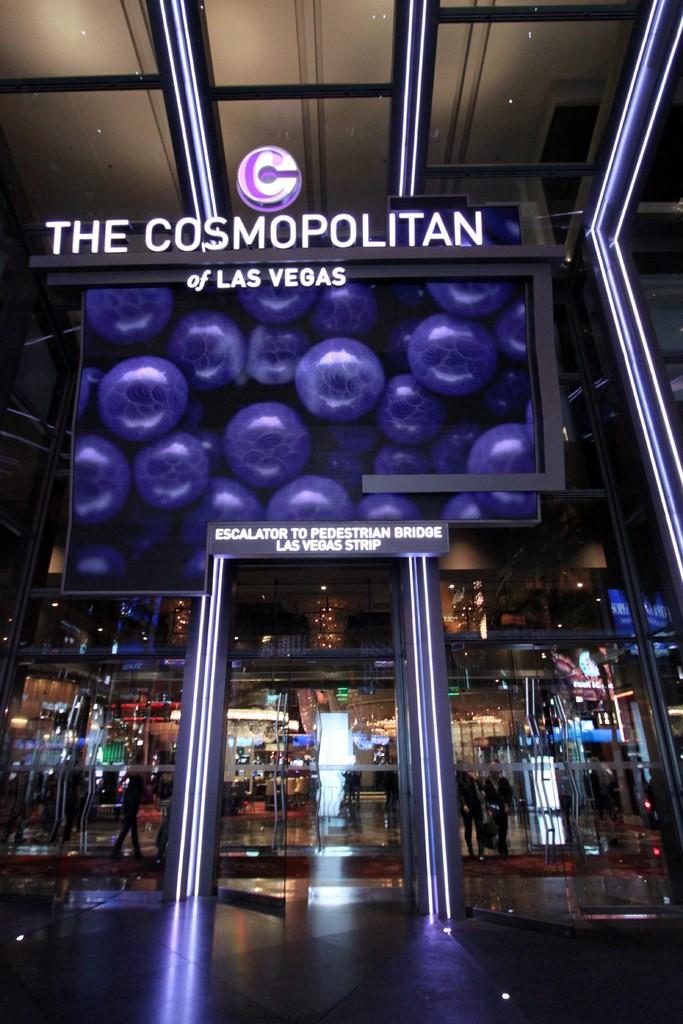In which city is this place?
Offer a very short reply. Las vegas. Where does the escalator advertised on the archway lead?
Your response must be concise. Pedestrian bridge. 